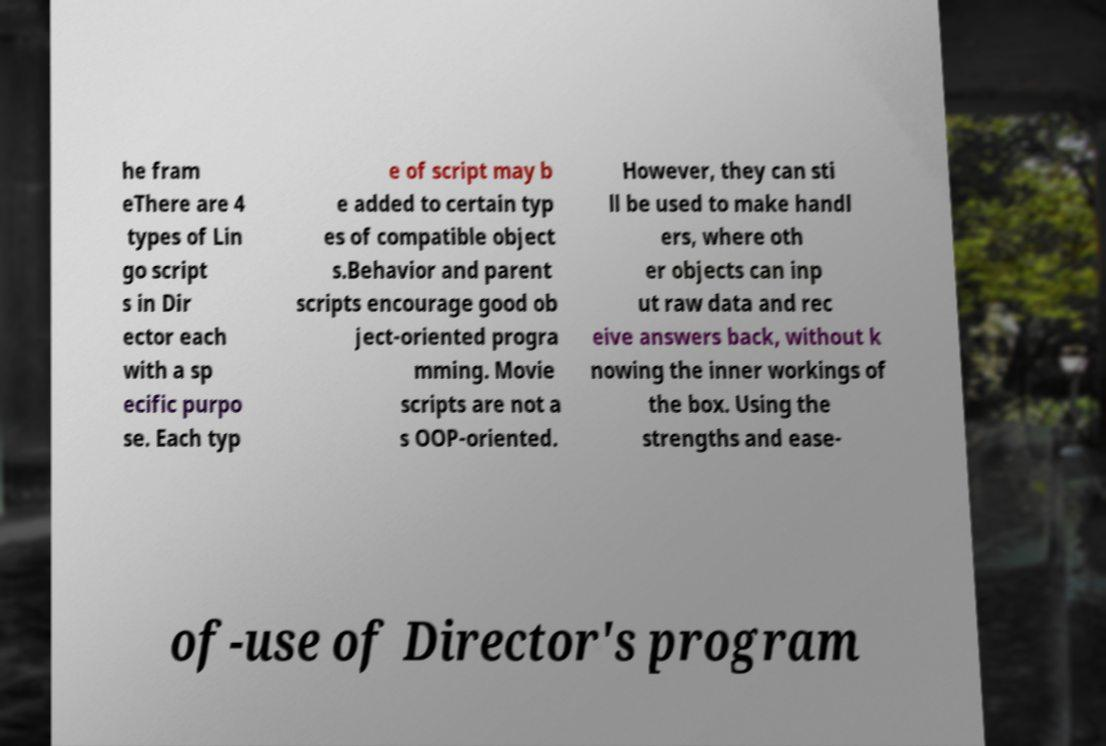Could you assist in decoding the text presented in this image and type it out clearly? he fram eThere are 4 types of Lin go script s in Dir ector each with a sp ecific purpo se. Each typ e of script may b e added to certain typ es of compatible object s.Behavior and parent scripts encourage good ob ject-oriented progra mming. Movie scripts are not a s OOP-oriented. However, they can sti ll be used to make handl ers, where oth er objects can inp ut raw data and rec eive answers back, without k nowing the inner workings of the box. Using the strengths and ease- of-use of Director's program 